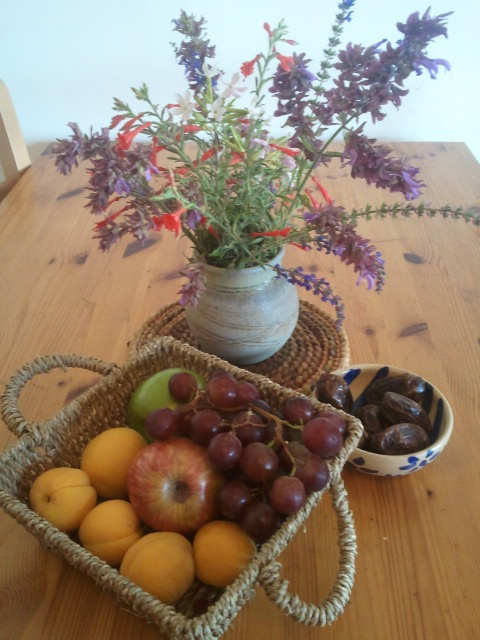Describe the objects in this image and their specific colors. I can see dining table in lightblue, tan, maroon, gray, and olive tones, potted plant in lightblue, gray, darkgray, and tan tones, bowl in lightblue, black, gray, and maroon tones, vase in lightblue, gray, darkgray, and maroon tones, and apple in lightblue, maroon, and brown tones in this image. 